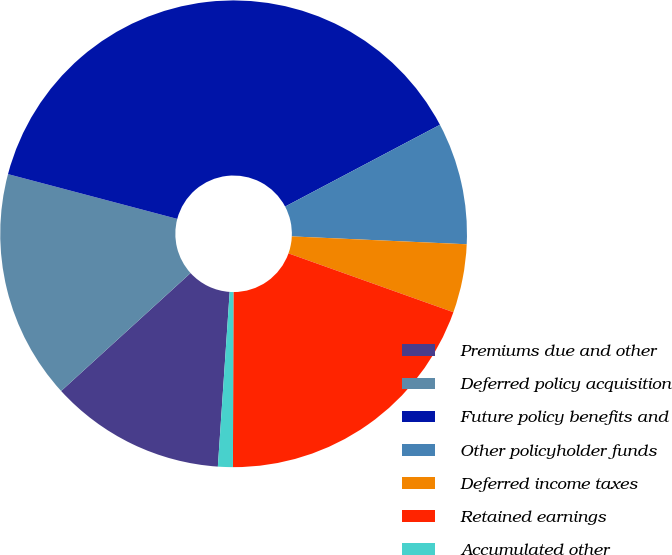<chart> <loc_0><loc_0><loc_500><loc_500><pie_chart><fcel>Premiums due and other<fcel>Deferred policy acquisition<fcel>Future policy benefits and<fcel>Other policyholder funds<fcel>Deferred income taxes<fcel>Retained earnings<fcel>Accumulated other<nl><fcel>12.16%<fcel>15.88%<fcel>38.15%<fcel>8.45%<fcel>4.74%<fcel>19.59%<fcel>1.03%<nl></chart> 